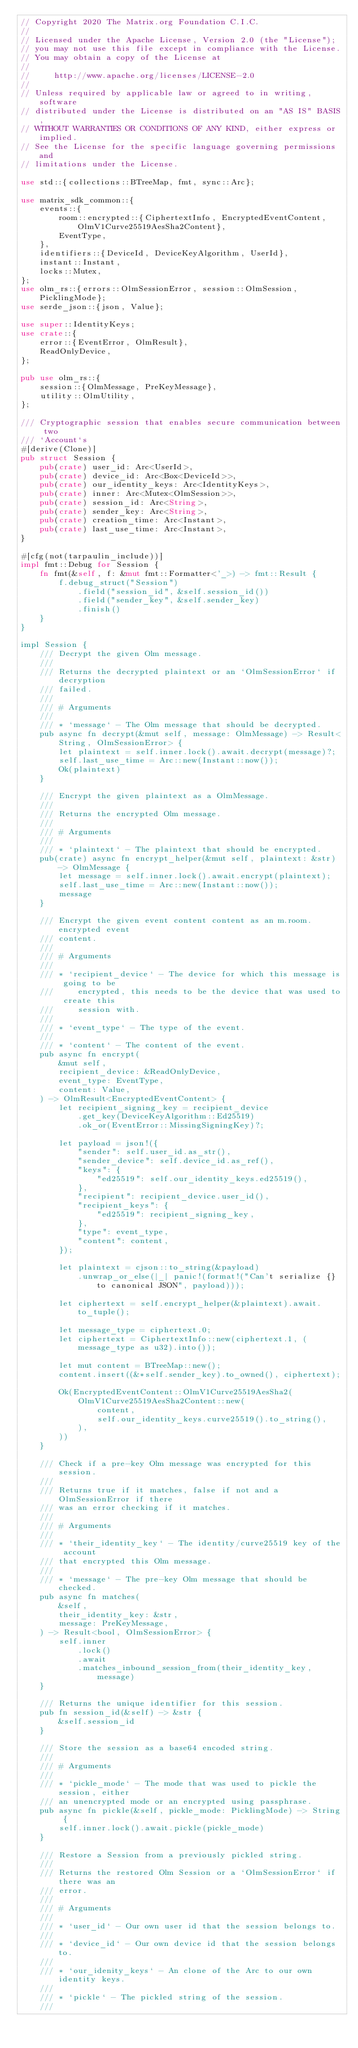Convert code to text. <code><loc_0><loc_0><loc_500><loc_500><_Rust_>// Copyright 2020 The Matrix.org Foundation C.I.C.
//
// Licensed under the Apache License, Version 2.0 (the "License");
// you may not use this file except in compliance with the License.
// You may obtain a copy of the License at
//
//     http://www.apache.org/licenses/LICENSE-2.0
//
// Unless required by applicable law or agreed to in writing, software
// distributed under the License is distributed on an "AS IS" BASIS,
// WITHOUT WARRANTIES OR CONDITIONS OF ANY KIND, either express or implied.
// See the License for the specific language governing permissions and
// limitations under the License.

use std::{collections::BTreeMap, fmt, sync::Arc};

use matrix_sdk_common::{
    events::{
        room::encrypted::{CiphertextInfo, EncryptedEventContent, OlmV1Curve25519AesSha2Content},
        EventType,
    },
    identifiers::{DeviceId, DeviceKeyAlgorithm, UserId},
    instant::Instant,
    locks::Mutex,
};
use olm_rs::{errors::OlmSessionError, session::OlmSession, PicklingMode};
use serde_json::{json, Value};

use super::IdentityKeys;
use crate::{
    error::{EventError, OlmResult},
    ReadOnlyDevice,
};

pub use olm_rs::{
    session::{OlmMessage, PreKeyMessage},
    utility::OlmUtility,
};

/// Cryptographic session that enables secure communication between two
/// `Account`s
#[derive(Clone)]
pub struct Session {
    pub(crate) user_id: Arc<UserId>,
    pub(crate) device_id: Arc<Box<DeviceId>>,
    pub(crate) our_identity_keys: Arc<IdentityKeys>,
    pub(crate) inner: Arc<Mutex<OlmSession>>,
    pub(crate) session_id: Arc<String>,
    pub(crate) sender_key: Arc<String>,
    pub(crate) creation_time: Arc<Instant>,
    pub(crate) last_use_time: Arc<Instant>,
}

#[cfg(not(tarpaulin_include))]
impl fmt::Debug for Session {
    fn fmt(&self, f: &mut fmt::Formatter<'_>) -> fmt::Result {
        f.debug_struct("Session")
            .field("session_id", &self.session_id())
            .field("sender_key", &self.sender_key)
            .finish()
    }
}

impl Session {
    /// Decrypt the given Olm message.
    ///
    /// Returns the decrypted plaintext or an `OlmSessionError` if decryption
    /// failed.
    ///
    /// # Arguments
    ///
    /// * `message` - The Olm message that should be decrypted.
    pub async fn decrypt(&mut self, message: OlmMessage) -> Result<String, OlmSessionError> {
        let plaintext = self.inner.lock().await.decrypt(message)?;
        self.last_use_time = Arc::new(Instant::now());
        Ok(plaintext)
    }

    /// Encrypt the given plaintext as a OlmMessage.
    ///
    /// Returns the encrypted Olm message.
    ///
    /// # Arguments
    ///
    /// * `plaintext` - The plaintext that should be encrypted.
    pub(crate) async fn encrypt_helper(&mut self, plaintext: &str) -> OlmMessage {
        let message = self.inner.lock().await.encrypt(plaintext);
        self.last_use_time = Arc::new(Instant::now());
        message
    }

    /// Encrypt the given event content content as an m.room.encrypted event
    /// content.
    ///
    /// # Arguments
    ///
    /// * `recipient_device` - The device for which this message is going to be
    ///     encrypted, this needs to be the device that was used to create this
    ///     session with.
    ///
    /// * `event_type` - The type of the event.
    ///
    /// * `content` - The content of the event.
    pub async fn encrypt(
        &mut self,
        recipient_device: &ReadOnlyDevice,
        event_type: EventType,
        content: Value,
    ) -> OlmResult<EncryptedEventContent> {
        let recipient_signing_key = recipient_device
            .get_key(DeviceKeyAlgorithm::Ed25519)
            .ok_or(EventError::MissingSigningKey)?;

        let payload = json!({
            "sender": self.user_id.as_str(),
            "sender_device": self.device_id.as_ref(),
            "keys": {
                "ed25519": self.our_identity_keys.ed25519(),
            },
            "recipient": recipient_device.user_id(),
            "recipient_keys": {
                "ed25519": recipient_signing_key,
            },
            "type": event_type,
            "content": content,
        });

        let plaintext = cjson::to_string(&payload)
            .unwrap_or_else(|_| panic!(format!("Can't serialize {} to canonical JSON", payload)));

        let ciphertext = self.encrypt_helper(&plaintext).await.to_tuple();

        let message_type = ciphertext.0;
        let ciphertext = CiphertextInfo::new(ciphertext.1, (message_type as u32).into());

        let mut content = BTreeMap::new();
        content.insert((&*self.sender_key).to_owned(), ciphertext);

        Ok(EncryptedEventContent::OlmV1Curve25519AesSha2(
            OlmV1Curve25519AesSha2Content::new(
                content,
                self.our_identity_keys.curve25519().to_string(),
            ),
        ))
    }

    /// Check if a pre-key Olm message was encrypted for this session.
    ///
    /// Returns true if it matches, false if not and a OlmSessionError if there
    /// was an error checking if it matches.
    ///
    /// # Arguments
    ///
    /// * `their_identity_key` - The identity/curve25519 key of the account
    /// that encrypted this Olm message.
    ///
    /// * `message` - The pre-key Olm message that should be checked.
    pub async fn matches(
        &self,
        their_identity_key: &str,
        message: PreKeyMessage,
    ) -> Result<bool, OlmSessionError> {
        self.inner
            .lock()
            .await
            .matches_inbound_session_from(their_identity_key, message)
    }

    /// Returns the unique identifier for this session.
    pub fn session_id(&self) -> &str {
        &self.session_id
    }

    /// Store the session as a base64 encoded string.
    ///
    /// # Arguments
    ///
    /// * `pickle_mode` - The mode that was used to pickle the session, either
    /// an unencrypted mode or an encrypted using passphrase.
    pub async fn pickle(&self, pickle_mode: PicklingMode) -> String {
        self.inner.lock().await.pickle(pickle_mode)
    }

    /// Restore a Session from a previously pickled string.
    ///
    /// Returns the restored Olm Session or a `OlmSessionError` if there was an
    /// error.
    ///
    /// # Arguments
    ///
    /// * `user_id` - Our own user id that the session belongs to.
    ///
    /// * `device_id` - Our own device id that the session belongs to.
    ///
    /// * `our_idenity_keys` - An clone of the Arc to our own identity keys.
    ///
    /// * `pickle` - The pickled string of the session.
    ///</code> 